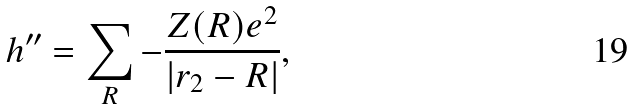<formula> <loc_0><loc_0><loc_500><loc_500>h ^ { \prime \prime } = \sum _ { R } - \frac { Z ( { R } ) e ^ { 2 } } { | { r } _ { 2 } - { R } | } ,</formula> 